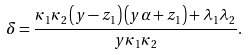<formula> <loc_0><loc_0><loc_500><loc_500>\delta = \frac { \kappa _ { 1 } \kappa _ { 2 } \left ( y - z _ { 1 } \right ) \left ( y \alpha + z _ { 1 } \right ) + \lambda _ { 1 } \lambda _ { 2 } } { y \kappa _ { 1 } \kappa _ { 2 } } .</formula> 